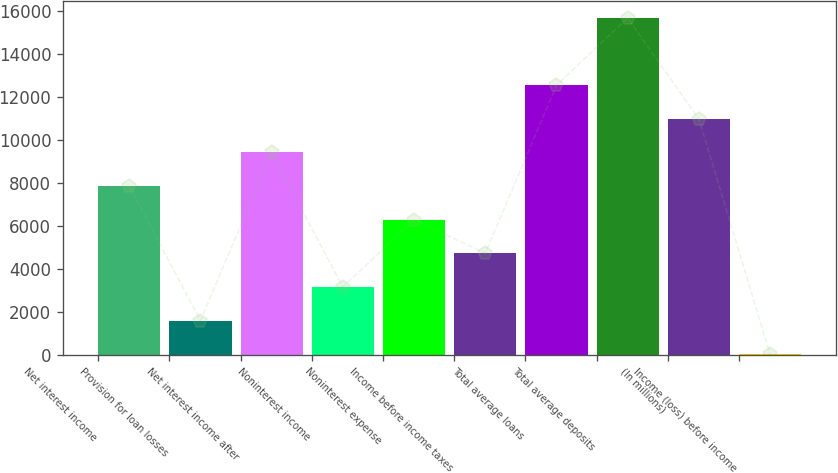Convert chart to OTSL. <chart><loc_0><loc_0><loc_500><loc_500><bar_chart><fcel>Net interest income<fcel>Provision for loan losses<fcel>Net interest income after<fcel>Noninterest income<fcel>Noninterest expense<fcel>Income before income taxes<fcel>Total average loans<fcel>Total average deposits<fcel>(In millions)<fcel>Income (loss) before income<nl><fcel>7853<fcel>1585<fcel>9420<fcel>3152<fcel>6286<fcel>4719<fcel>12554<fcel>15688<fcel>10987<fcel>18<nl></chart> 